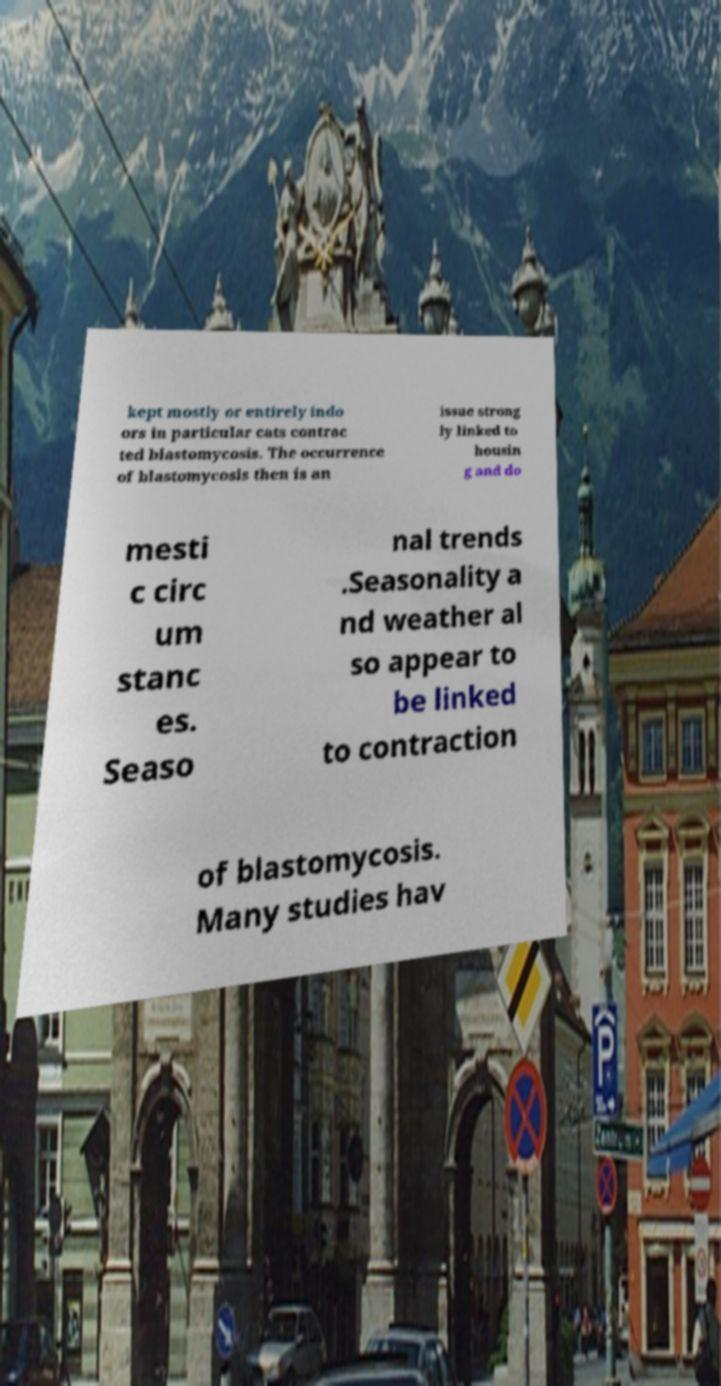What messages or text are displayed in this image? I need them in a readable, typed format. kept mostly or entirely indo ors in particular cats contrac ted blastomycosis. The occurrence of blastomycosis then is an issue strong ly linked to housin g and do mesti c circ um stanc es. Seaso nal trends .Seasonality a nd weather al so appear to be linked to contraction of blastomycosis. Many studies hav 